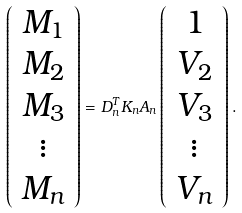<formula> <loc_0><loc_0><loc_500><loc_500>\left ( \begin{array} { c } M _ { 1 } \\ M _ { 2 } \\ M _ { 3 } \\ \vdots \\ M _ { n } \end{array} \right ) = D _ { n } ^ { T } K _ { n } A _ { n } \left ( \begin{array} { c } 1 \\ V _ { 2 } \\ V _ { 3 } \\ \vdots \\ V _ { n } \end{array} \right ) .</formula> 